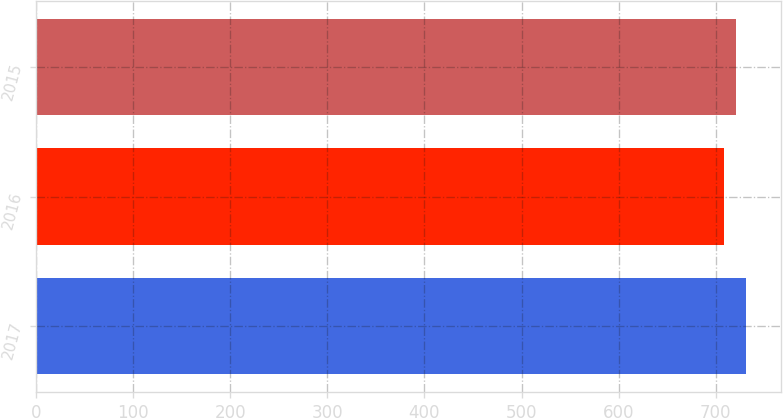Convert chart. <chart><loc_0><loc_0><loc_500><loc_500><bar_chart><fcel>2017<fcel>2016<fcel>2015<nl><fcel>731<fcel>708<fcel>721<nl></chart> 